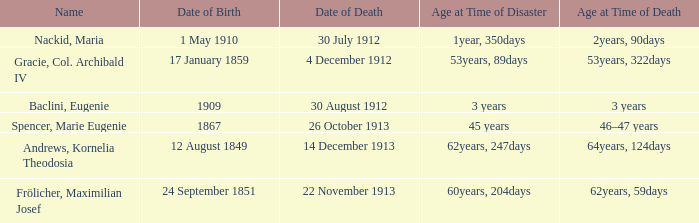How old was the person born 24 September 1851 at the time of disaster? 60years, 204days. 